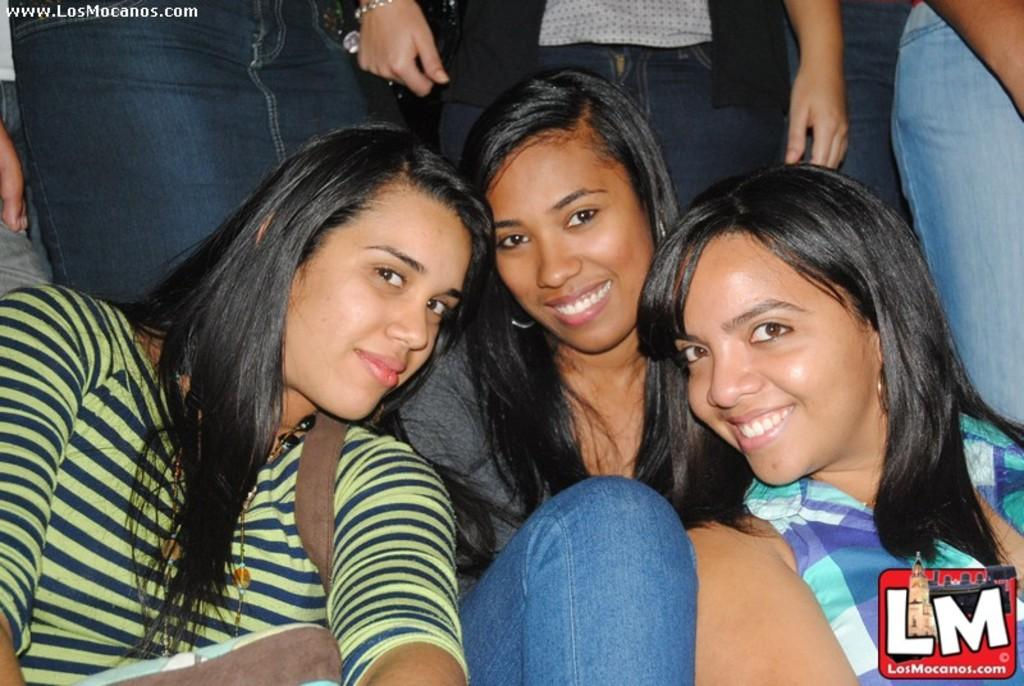What is the main subject of the image? The main subject of the image is the girls sitting in the center. Can you describe the position of the other people in the image? The other people are located at the top side of the image. What type of bait is being used by the girls in the image? There is no mention of bait or fishing in the image, so it cannot be determined if any bait is being used. 